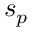<formula> <loc_0><loc_0><loc_500><loc_500>s _ { p }</formula> 